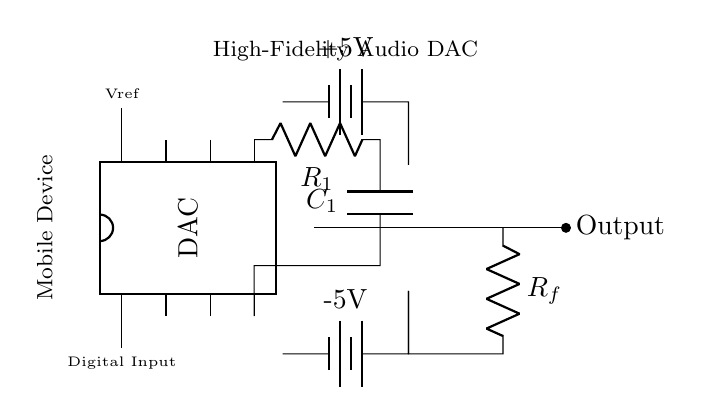What component provides the digital input to the DAC? The DAC has a pin labeled as "Digital Input," which directly connects to the input signal for digital-to-analog conversion.
Answer: Digital Input What is the reference voltage for the DAC? The DAC is provided with a reference voltage labeled "Vref" on pin 8, which sets the level for the output signal.
Answer: Vref Which components form the low-pass filter in this circuit? The low-pass filter is formed by a resistor labeled "R1" and a capacitor labeled "C1," which are connected in series followed by a short connection back to the DAC.
Answer: R1 and C1 What type of amplifier is used in this circuit? The circuit includes an operational amplifier, indicated by the op-amp symbol, which is commonly used for amplifying signals.
Answer: Operational amplifier How is the output of the circuit indicated? The output of the circuit is indicated by a connection leading to an empty circle labeled "Output," which indicates where the amplified analog signal will be taken from.
Answer: Output What are the voltage levels supplied to the circuit? The circuit is powered by a positive 5V battery and a negative 5V battery, which are labeled accordingly, providing dual power supply for proper operation of the OP-AMP.
Answer: +5V and -5V How does the feedback network relate to the op-amp? The feedback network, represented by the resistor labeled "Rf," connects the output of the op-amp back to its inverting input, which controls the gain and behavior of the op-amp's output.
Answer: Rf 